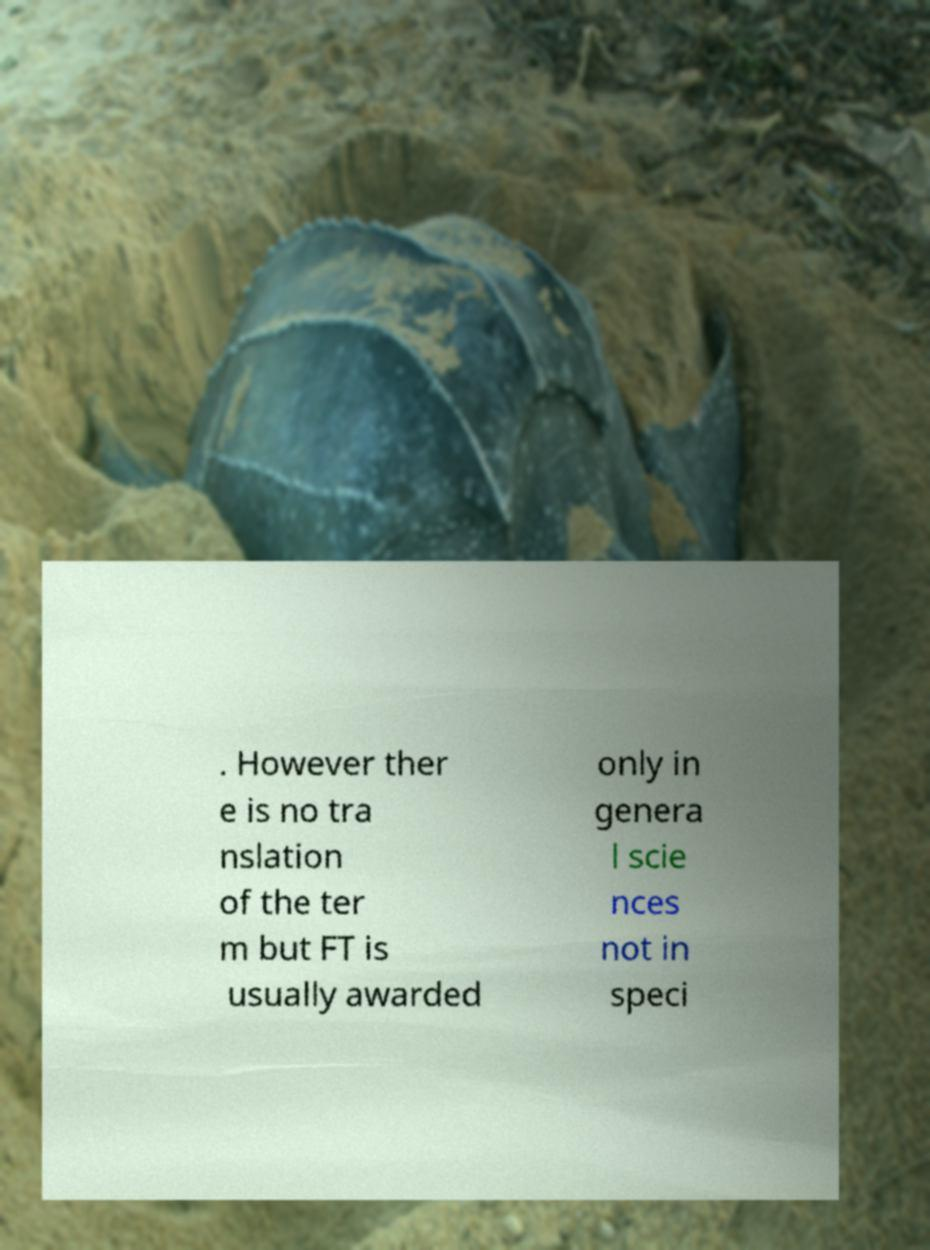Please read and relay the text visible in this image. What does it say? . However ther e is no tra nslation of the ter m but FT is usually awarded only in genera l scie nces not in speci 